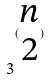Convert formula to latex. <formula><loc_0><loc_0><loc_500><loc_500>3 ^ { ( \begin{matrix} n \\ 2 \end{matrix} ) }</formula> 